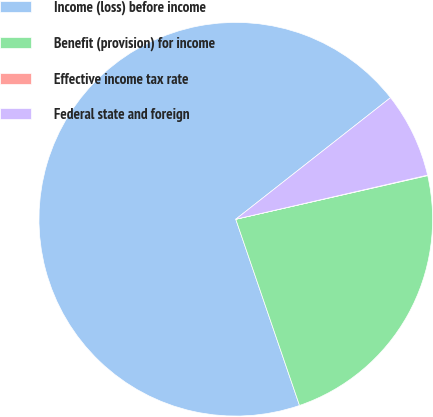<chart> <loc_0><loc_0><loc_500><loc_500><pie_chart><fcel>Income (loss) before income<fcel>Benefit (provision) for income<fcel>Effective income tax rate<fcel>Federal state and foreign<nl><fcel>69.65%<fcel>23.31%<fcel>0.04%<fcel>7.0%<nl></chart> 